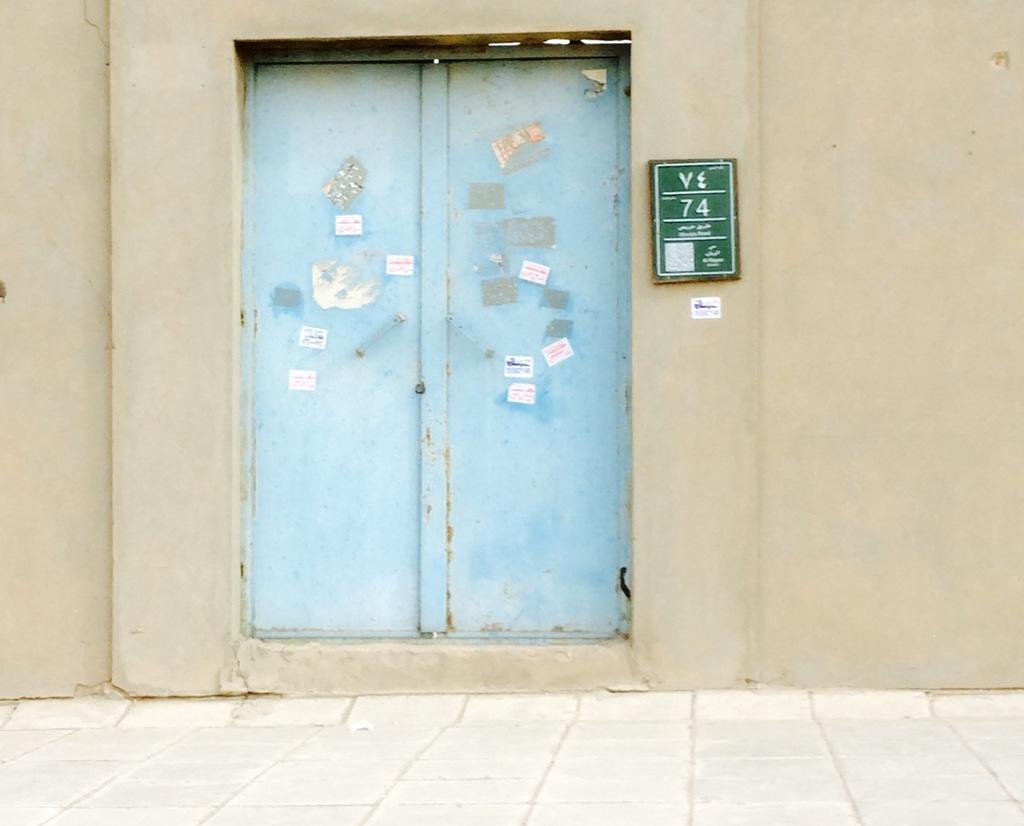What is the main subject of the image? The main subject of the image is the door of a house. Are there any additional features on the door? Yes, there are labels stuck to the door. What can be seen attached to the wall in the image? There is a board attached to the wall in the image. What type of skin condition can be seen on the door in the image? There is no skin condition present on the door in the image. How many fingers are visible on the door in the image? There are no fingers visible on the door in the image. 